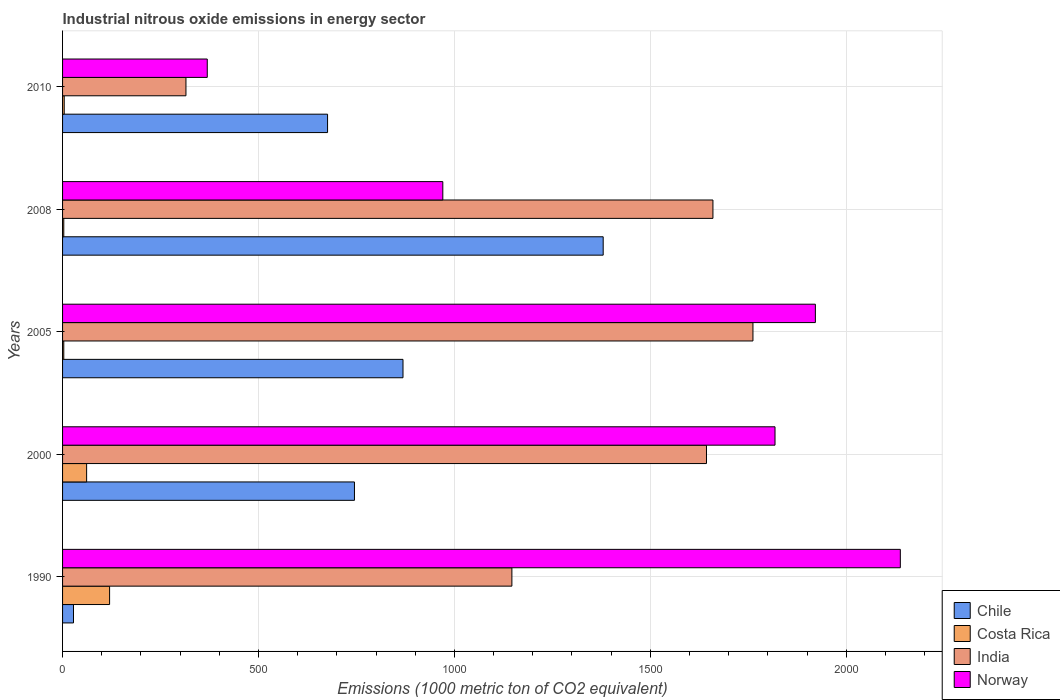How many bars are there on the 2nd tick from the bottom?
Offer a terse response. 4. In how many cases, is the number of bars for a given year not equal to the number of legend labels?
Ensure brevity in your answer.  0. Across all years, what is the maximum amount of industrial nitrous oxide emitted in Chile?
Your response must be concise. 1379.7. Across all years, what is the minimum amount of industrial nitrous oxide emitted in Chile?
Provide a succinct answer. 27.9. What is the total amount of industrial nitrous oxide emitted in India in the graph?
Your response must be concise. 6526.6. What is the difference between the amount of industrial nitrous oxide emitted in Costa Rica in 1990 and that in 2005?
Make the answer very short. 116.9. What is the difference between the amount of industrial nitrous oxide emitted in Chile in 1990 and the amount of industrial nitrous oxide emitted in Costa Rica in 2010?
Your response must be concise. 23.7. What is the average amount of industrial nitrous oxide emitted in India per year?
Make the answer very short. 1305.32. In the year 2010, what is the difference between the amount of industrial nitrous oxide emitted in Chile and amount of industrial nitrous oxide emitted in Costa Rica?
Provide a succinct answer. 672.1. In how many years, is the amount of industrial nitrous oxide emitted in Costa Rica greater than 700 1000 metric ton?
Provide a short and direct response. 0. What is the ratio of the amount of industrial nitrous oxide emitted in Norway in 2005 to that in 2010?
Offer a terse response. 5.2. Is the amount of industrial nitrous oxide emitted in India in 1990 less than that in 2000?
Keep it short and to the point. Yes. What is the difference between the highest and the second highest amount of industrial nitrous oxide emitted in Costa Rica?
Ensure brevity in your answer.  58.6. What is the difference between the highest and the lowest amount of industrial nitrous oxide emitted in Chile?
Provide a short and direct response. 1351.8. Is the sum of the amount of industrial nitrous oxide emitted in Norway in 1990 and 2010 greater than the maximum amount of industrial nitrous oxide emitted in India across all years?
Give a very brief answer. Yes. Is it the case that in every year, the sum of the amount of industrial nitrous oxide emitted in Chile and amount of industrial nitrous oxide emitted in India is greater than the sum of amount of industrial nitrous oxide emitted in Norway and amount of industrial nitrous oxide emitted in Costa Rica?
Ensure brevity in your answer.  Yes. What does the 1st bar from the top in 2005 represents?
Keep it short and to the point. Norway. What does the 4th bar from the bottom in 2008 represents?
Your answer should be compact. Norway. Is it the case that in every year, the sum of the amount of industrial nitrous oxide emitted in Costa Rica and amount of industrial nitrous oxide emitted in India is greater than the amount of industrial nitrous oxide emitted in Chile?
Your response must be concise. No. How many years are there in the graph?
Provide a short and direct response. 5. What is the difference between two consecutive major ticks on the X-axis?
Make the answer very short. 500. Does the graph contain any zero values?
Offer a terse response. No. How many legend labels are there?
Offer a terse response. 4. How are the legend labels stacked?
Provide a succinct answer. Vertical. What is the title of the graph?
Give a very brief answer. Industrial nitrous oxide emissions in energy sector. What is the label or title of the X-axis?
Give a very brief answer. Emissions (1000 metric ton of CO2 equivalent). What is the label or title of the Y-axis?
Your response must be concise. Years. What is the Emissions (1000 metric ton of CO2 equivalent) in Chile in 1990?
Ensure brevity in your answer.  27.9. What is the Emissions (1000 metric ton of CO2 equivalent) in Costa Rica in 1990?
Make the answer very short. 120. What is the Emissions (1000 metric ton of CO2 equivalent) of India in 1990?
Offer a terse response. 1146.7. What is the Emissions (1000 metric ton of CO2 equivalent) in Norway in 1990?
Ensure brevity in your answer.  2138. What is the Emissions (1000 metric ton of CO2 equivalent) of Chile in 2000?
Your answer should be compact. 744.9. What is the Emissions (1000 metric ton of CO2 equivalent) of Costa Rica in 2000?
Provide a succinct answer. 61.4. What is the Emissions (1000 metric ton of CO2 equivalent) of India in 2000?
Keep it short and to the point. 1643.3. What is the Emissions (1000 metric ton of CO2 equivalent) in Norway in 2000?
Provide a succinct answer. 1818.2. What is the Emissions (1000 metric ton of CO2 equivalent) in Chile in 2005?
Make the answer very short. 868.8. What is the Emissions (1000 metric ton of CO2 equivalent) of Costa Rica in 2005?
Your answer should be compact. 3.1. What is the Emissions (1000 metric ton of CO2 equivalent) in India in 2005?
Your answer should be compact. 1761.9. What is the Emissions (1000 metric ton of CO2 equivalent) in Norway in 2005?
Offer a very short reply. 1921.2. What is the Emissions (1000 metric ton of CO2 equivalent) of Chile in 2008?
Your answer should be compact. 1379.7. What is the Emissions (1000 metric ton of CO2 equivalent) of Costa Rica in 2008?
Your response must be concise. 3.1. What is the Emissions (1000 metric ton of CO2 equivalent) of India in 2008?
Your response must be concise. 1659.8. What is the Emissions (1000 metric ton of CO2 equivalent) in Norway in 2008?
Give a very brief answer. 970.4. What is the Emissions (1000 metric ton of CO2 equivalent) of Chile in 2010?
Provide a short and direct response. 676.3. What is the Emissions (1000 metric ton of CO2 equivalent) of Costa Rica in 2010?
Offer a terse response. 4.2. What is the Emissions (1000 metric ton of CO2 equivalent) in India in 2010?
Your response must be concise. 314.9. What is the Emissions (1000 metric ton of CO2 equivalent) in Norway in 2010?
Make the answer very short. 369.3. Across all years, what is the maximum Emissions (1000 metric ton of CO2 equivalent) in Chile?
Your response must be concise. 1379.7. Across all years, what is the maximum Emissions (1000 metric ton of CO2 equivalent) of Costa Rica?
Give a very brief answer. 120. Across all years, what is the maximum Emissions (1000 metric ton of CO2 equivalent) in India?
Your answer should be very brief. 1761.9. Across all years, what is the maximum Emissions (1000 metric ton of CO2 equivalent) in Norway?
Ensure brevity in your answer.  2138. Across all years, what is the minimum Emissions (1000 metric ton of CO2 equivalent) of Chile?
Your answer should be very brief. 27.9. Across all years, what is the minimum Emissions (1000 metric ton of CO2 equivalent) of India?
Offer a terse response. 314.9. Across all years, what is the minimum Emissions (1000 metric ton of CO2 equivalent) in Norway?
Your response must be concise. 369.3. What is the total Emissions (1000 metric ton of CO2 equivalent) in Chile in the graph?
Offer a very short reply. 3697.6. What is the total Emissions (1000 metric ton of CO2 equivalent) in Costa Rica in the graph?
Provide a short and direct response. 191.8. What is the total Emissions (1000 metric ton of CO2 equivalent) in India in the graph?
Your answer should be very brief. 6526.6. What is the total Emissions (1000 metric ton of CO2 equivalent) in Norway in the graph?
Provide a short and direct response. 7217.1. What is the difference between the Emissions (1000 metric ton of CO2 equivalent) of Chile in 1990 and that in 2000?
Offer a very short reply. -717. What is the difference between the Emissions (1000 metric ton of CO2 equivalent) in Costa Rica in 1990 and that in 2000?
Make the answer very short. 58.6. What is the difference between the Emissions (1000 metric ton of CO2 equivalent) of India in 1990 and that in 2000?
Make the answer very short. -496.6. What is the difference between the Emissions (1000 metric ton of CO2 equivalent) of Norway in 1990 and that in 2000?
Provide a short and direct response. 319.8. What is the difference between the Emissions (1000 metric ton of CO2 equivalent) of Chile in 1990 and that in 2005?
Your answer should be very brief. -840.9. What is the difference between the Emissions (1000 metric ton of CO2 equivalent) of Costa Rica in 1990 and that in 2005?
Make the answer very short. 116.9. What is the difference between the Emissions (1000 metric ton of CO2 equivalent) in India in 1990 and that in 2005?
Offer a terse response. -615.2. What is the difference between the Emissions (1000 metric ton of CO2 equivalent) of Norway in 1990 and that in 2005?
Ensure brevity in your answer.  216.8. What is the difference between the Emissions (1000 metric ton of CO2 equivalent) of Chile in 1990 and that in 2008?
Give a very brief answer. -1351.8. What is the difference between the Emissions (1000 metric ton of CO2 equivalent) of Costa Rica in 1990 and that in 2008?
Provide a short and direct response. 116.9. What is the difference between the Emissions (1000 metric ton of CO2 equivalent) in India in 1990 and that in 2008?
Offer a very short reply. -513.1. What is the difference between the Emissions (1000 metric ton of CO2 equivalent) of Norway in 1990 and that in 2008?
Your answer should be very brief. 1167.6. What is the difference between the Emissions (1000 metric ton of CO2 equivalent) of Chile in 1990 and that in 2010?
Ensure brevity in your answer.  -648.4. What is the difference between the Emissions (1000 metric ton of CO2 equivalent) of Costa Rica in 1990 and that in 2010?
Offer a terse response. 115.8. What is the difference between the Emissions (1000 metric ton of CO2 equivalent) of India in 1990 and that in 2010?
Give a very brief answer. 831.8. What is the difference between the Emissions (1000 metric ton of CO2 equivalent) in Norway in 1990 and that in 2010?
Give a very brief answer. 1768.7. What is the difference between the Emissions (1000 metric ton of CO2 equivalent) in Chile in 2000 and that in 2005?
Your response must be concise. -123.9. What is the difference between the Emissions (1000 metric ton of CO2 equivalent) in Costa Rica in 2000 and that in 2005?
Offer a very short reply. 58.3. What is the difference between the Emissions (1000 metric ton of CO2 equivalent) in India in 2000 and that in 2005?
Your answer should be very brief. -118.6. What is the difference between the Emissions (1000 metric ton of CO2 equivalent) of Norway in 2000 and that in 2005?
Ensure brevity in your answer.  -103. What is the difference between the Emissions (1000 metric ton of CO2 equivalent) of Chile in 2000 and that in 2008?
Give a very brief answer. -634.8. What is the difference between the Emissions (1000 metric ton of CO2 equivalent) of Costa Rica in 2000 and that in 2008?
Ensure brevity in your answer.  58.3. What is the difference between the Emissions (1000 metric ton of CO2 equivalent) in India in 2000 and that in 2008?
Make the answer very short. -16.5. What is the difference between the Emissions (1000 metric ton of CO2 equivalent) in Norway in 2000 and that in 2008?
Offer a terse response. 847.8. What is the difference between the Emissions (1000 metric ton of CO2 equivalent) in Chile in 2000 and that in 2010?
Give a very brief answer. 68.6. What is the difference between the Emissions (1000 metric ton of CO2 equivalent) in Costa Rica in 2000 and that in 2010?
Your answer should be very brief. 57.2. What is the difference between the Emissions (1000 metric ton of CO2 equivalent) of India in 2000 and that in 2010?
Make the answer very short. 1328.4. What is the difference between the Emissions (1000 metric ton of CO2 equivalent) in Norway in 2000 and that in 2010?
Ensure brevity in your answer.  1448.9. What is the difference between the Emissions (1000 metric ton of CO2 equivalent) of Chile in 2005 and that in 2008?
Your response must be concise. -510.9. What is the difference between the Emissions (1000 metric ton of CO2 equivalent) of India in 2005 and that in 2008?
Keep it short and to the point. 102.1. What is the difference between the Emissions (1000 metric ton of CO2 equivalent) of Norway in 2005 and that in 2008?
Provide a short and direct response. 950.8. What is the difference between the Emissions (1000 metric ton of CO2 equivalent) of Chile in 2005 and that in 2010?
Keep it short and to the point. 192.5. What is the difference between the Emissions (1000 metric ton of CO2 equivalent) of India in 2005 and that in 2010?
Provide a succinct answer. 1447. What is the difference between the Emissions (1000 metric ton of CO2 equivalent) in Norway in 2005 and that in 2010?
Offer a very short reply. 1551.9. What is the difference between the Emissions (1000 metric ton of CO2 equivalent) of Chile in 2008 and that in 2010?
Your answer should be compact. 703.4. What is the difference between the Emissions (1000 metric ton of CO2 equivalent) in India in 2008 and that in 2010?
Keep it short and to the point. 1344.9. What is the difference between the Emissions (1000 metric ton of CO2 equivalent) in Norway in 2008 and that in 2010?
Keep it short and to the point. 601.1. What is the difference between the Emissions (1000 metric ton of CO2 equivalent) in Chile in 1990 and the Emissions (1000 metric ton of CO2 equivalent) in Costa Rica in 2000?
Ensure brevity in your answer.  -33.5. What is the difference between the Emissions (1000 metric ton of CO2 equivalent) of Chile in 1990 and the Emissions (1000 metric ton of CO2 equivalent) of India in 2000?
Offer a very short reply. -1615.4. What is the difference between the Emissions (1000 metric ton of CO2 equivalent) of Chile in 1990 and the Emissions (1000 metric ton of CO2 equivalent) of Norway in 2000?
Make the answer very short. -1790.3. What is the difference between the Emissions (1000 metric ton of CO2 equivalent) in Costa Rica in 1990 and the Emissions (1000 metric ton of CO2 equivalent) in India in 2000?
Give a very brief answer. -1523.3. What is the difference between the Emissions (1000 metric ton of CO2 equivalent) of Costa Rica in 1990 and the Emissions (1000 metric ton of CO2 equivalent) of Norway in 2000?
Your response must be concise. -1698.2. What is the difference between the Emissions (1000 metric ton of CO2 equivalent) of India in 1990 and the Emissions (1000 metric ton of CO2 equivalent) of Norway in 2000?
Provide a short and direct response. -671.5. What is the difference between the Emissions (1000 metric ton of CO2 equivalent) of Chile in 1990 and the Emissions (1000 metric ton of CO2 equivalent) of Costa Rica in 2005?
Your answer should be compact. 24.8. What is the difference between the Emissions (1000 metric ton of CO2 equivalent) in Chile in 1990 and the Emissions (1000 metric ton of CO2 equivalent) in India in 2005?
Provide a short and direct response. -1734. What is the difference between the Emissions (1000 metric ton of CO2 equivalent) in Chile in 1990 and the Emissions (1000 metric ton of CO2 equivalent) in Norway in 2005?
Offer a very short reply. -1893.3. What is the difference between the Emissions (1000 metric ton of CO2 equivalent) of Costa Rica in 1990 and the Emissions (1000 metric ton of CO2 equivalent) of India in 2005?
Keep it short and to the point. -1641.9. What is the difference between the Emissions (1000 metric ton of CO2 equivalent) of Costa Rica in 1990 and the Emissions (1000 metric ton of CO2 equivalent) of Norway in 2005?
Your answer should be compact. -1801.2. What is the difference between the Emissions (1000 metric ton of CO2 equivalent) of India in 1990 and the Emissions (1000 metric ton of CO2 equivalent) of Norway in 2005?
Provide a short and direct response. -774.5. What is the difference between the Emissions (1000 metric ton of CO2 equivalent) of Chile in 1990 and the Emissions (1000 metric ton of CO2 equivalent) of Costa Rica in 2008?
Provide a short and direct response. 24.8. What is the difference between the Emissions (1000 metric ton of CO2 equivalent) in Chile in 1990 and the Emissions (1000 metric ton of CO2 equivalent) in India in 2008?
Make the answer very short. -1631.9. What is the difference between the Emissions (1000 metric ton of CO2 equivalent) of Chile in 1990 and the Emissions (1000 metric ton of CO2 equivalent) of Norway in 2008?
Provide a succinct answer. -942.5. What is the difference between the Emissions (1000 metric ton of CO2 equivalent) in Costa Rica in 1990 and the Emissions (1000 metric ton of CO2 equivalent) in India in 2008?
Give a very brief answer. -1539.8. What is the difference between the Emissions (1000 metric ton of CO2 equivalent) of Costa Rica in 1990 and the Emissions (1000 metric ton of CO2 equivalent) of Norway in 2008?
Offer a very short reply. -850.4. What is the difference between the Emissions (1000 metric ton of CO2 equivalent) of India in 1990 and the Emissions (1000 metric ton of CO2 equivalent) of Norway in 2008?
Offer a terse response. 176.3. What is the difference between the Emissions (1000 metric ton of CO2 equivalent) of Chile in 1990 and the Emissions (1000 metric ton of CO2 equivalent) of Costa Rica in 2010?
Give a very brief answer. 23.7. What is the difference between the Emissions (1000 metric ton of CO2 equivalent) in Chile in 1990 and the Emissions (1000 metric ton of CO2 equivalent) in India in 2010?
Make the answer very short. -287. What is the difference between the Emissions (1000 metric ton of CO2 equivalent) of Chile in 1990 and the Emissions (1000 metric ton of CO2 equivalent) of Norway in 2010?
Keep it short and to the point. -341.4. What is the difference between the Emissions (1000 metric ton of CO2 equivalent) of Costa Rica in 1990 and the Emissions (1000 metric ton of CO2 equivalent) of India in 2010?
Ensure brevity in your answer.  -194.9. What is the difference between the Emissions (1000 metric ton of CO2 equivalent) in Costa Rica in 1990 and the Emissions (1000 metric ton of CO2 equivalent) in Norway in 2010?
Your answer should be compact. -249.3. What is the difference between the Emissions (1000 metric ton of CO2 equivalent) of India in 1990 and the Emissions (1000 metric ton of CO2 equivalent) of Norway in 2010?
Your answer should be very brief. 777.4. What is the difference between the Emissions (1000 metric ton of CO2 equivalent) in Chile in 2000 and the Emissions (1000 metric ton of CO2 equivalent) in Costa Rica in 2005?
Keep it short and to the point. 741.8. What is the difference between the Emissions (1000 metric ton of CO2 equivalent) in Chile in 2000 and the Emissions (1000 metric ton of CO2 equivalent) in India in 2005?
Offer a terse response. -1017. What is the difference between the Emissions (1000 metric ton of CO2 equivalent) of Chile in 2000 and the Emissions (1000 metric ton of CO2 equivalent) of Norway in 2005?
Your response must be concise. -1176.3. What is the difference between the Emissions (1000 metric ton of CO2 equivalent) of Costa Rica in 2000 and the Emissions (1000 metric ton of CO2 equivalent) of India in 2005?
Provide a succinct answer. -1700.5. What is the difference between the Emissions (1000 metric ton of CO2 equivalent) of Costa Rica in 2000 and the Emissions (1000 metric ton of CO2 equivalent) of Norway in 2005?
Keep it short and to the point. -1859.8. What is the difference between the Emissions (1000 metric ton of CO2 equivalent) of India in 2000 and the Emissions (1000 metric ton of CO2 equivalent) of Norway in 2005?
Offer a very short reply. -277.9. What is the difference between the Emissions (1000 metric ton of CO2 equivalent) in Chile in 2000 and the Emissions (1000 metric ton of CO2 equivalent) in Costa Rica in 2008?
Give a very brief answer. 741.8. What is the difference between the Emissions (1000 metric ton of CO2 equivalent) of Chile in 2000 and the Emissions (1000 metric ton of CO2 equivalent) of India in 2008?
Your response must be concise. -914.9. What is the difference between the Emissions (1000 metric ton of CO2 equivalent) of Chile in 2000 and the Emissions (1000 metric ton of CO2 equivalent) of Norway in 2008?
Offer a very short reply. -225.5. What is the difference between the Emissions (1000 metric ton of CO2 equivalent) in Costa Rica in 2000 and the Emissions (1000 metric ton of CO2 equivalent) in India in 2008?
Offer a very short reply. -1598.4. What is the difference between the Emissions (1000 metric ton of CO2 equivalent) of Costa Rica in 2000 and the Emissions (1000 metric ton of CO2 equivalent) of Norway in 2008?
Give a very brief answer. -909. What is the difference between the Emissions (1000 metric ton of CO2 equivalent) of India in 2000 and the Emissions (1000 metric ton of CO2 equivalent) of Norway in 2008?
Offer a very short reply. 672.9. What is the difference between the Emissions (1000 metric ton of CO2 equivalent) in Chile in 2000 and the Emissions (1000 metric ton of CO2 equivalent) in Costa Rica in 2010?
Offer a very short reply. 740.7. What is the difference between the Emissions (1000 metric ton of CO2 equivalent) of Chile in 2000 and the Emissions (1000 metric ton of CO2 equivalent) of India in 2010?
Ensure brevity in your answer.  430. What is the difference between the Emissions (1000 metric ton of CO2 equivalent) in Chile in 2000 and the Emissions (1000 metric ton of CO2 equivalent) in Norway in 2010?
Give a very brief answer. 375.6. What is the difference between the Emissions (1000 metric ton of CO2 equivalent) of Costa Rica in 2000 and the Emissions (1000 metric ton of CO2 equivalent) of India in 2010?
Give a very brief answer. -253.5. What is the difference between the Emissions (1000 metric ton of CO2 equivalent) in Costa Rica in 2000 and the Emissions (1000 metric ton of CO2 equivalent) in Norway in 2010?
Offer a very short reply. -307.9. What is the difference between the Emissions (1000 metric ton of CO2 equivalent) in India in 2000 and the Emissions (1000 metric ton of CO2 equivalent) in Norway in 2010?
Offer a terse response. 1274. What is the difference between the Emissions (1000 metric ton of CO2 equivalent) in Chile in 2005 and the Emissions (1000 metric ton of CO2 equivalent) in Costa Rica in 2008?
Your answer should be very brief. 865.7. What is the difference between the Emissions (1000 metric ton of CO2 equivalent) in Chile in 2005 and the Emissions (1000 metric ton of CO2 equivalent) in India in 2008?
Provide a short and direct response. -791. What is the difference between the Emissions (1000 metric ton of CO2 equivalent) in Chile in 2005 and the Emissions (1000 metric ton of CO2 equivalent) in Norway in 2008?
Provide a succinct answer. -101.6. What is the difference between the Emissions (1000 metric ton of CO2 equivalent) in Costa Rica in 2005 and the Emissions (1000 metric ton of CO2 equivalent) in India in 2008?
Give a very brief answer. -1656.7. What is the difference between the Emissions (1000 metric ton of CO2 equivalent) in Costa Rica in 2005 and the Emissions (1000 metric ton of CO2 equivalent) in Norway in 2008?
Offer a terse response. -967.3. What is the difference between the Emissions (1000 metric ton of CO2 equivalent) of India in 2005 and the Emissions (1000 metric ton of CO2 equivalent) of Norway in 2008?
Provide a succinct answer. 791.5. What is the difference between the Emissions (1000 metric ton of CO2 equivalent) in Chile in 2005 and the Emissions (1000 metric ton of CO2 equivalent) in Costa Rica in 2010?
Make the answer very short. 864.6. What is the difference between the Emissions (1000 metric ton of CO2 equivalent) of Chile in 2005 and the Emissions (1000 metric ton of CO2 equivalent) of India in 2010?
Keep it short and to the point. 553.9. What is the difference between the Emissions (1000 metric ton of CO2 equivalent) in Chile in 2005 and the Emissions (1000 metric ton of CO2 equivalent) in Norway in 2010?
Your answer should be very brief. 499.5. What is the difference between the Emissions (1000 metric ton of CO2 equivalent) of Costa Rica in 2005 and the Emissions (1000 metric ton of CO2 equivalent) of India in 2010?
Your answer should be compact. -311.8. What is the difference between the Emissions (1000 metric ton of CO2 equivalent) of Costa Rica in 2005 and the Emissions (1000 metric ton of CO2 equivalent) of Norway in 2010?
Your response must be concise. -366.2. What is the difference between the Emissions (1000 metric ton of CO2 equivalent) of India in 2005 and the Emissions (1000 metric ton of CO2 equivalent) of Norway in 2010?
Offer a very short reply. 1392.6. What is the difference between the Emissions (1000 metric ton of CO2 equivalent) in Chile in 2008 and the Emissions (1000 metric ton of CO2 equivalent) in Costa Rica in 2010?
Give a very brief answer. 1375.5. What is the difference between the Emissions (1000 metric ton of CO2 equivalent) of Chile in 2008 and the Emissions (1000 metric ton of CO2 equivalent) of India in 2010?
Provide a short and direct response. 1064.8. What is the difference between the Emissions (1000 metric ton of CO2 equivalent) of Chile in 2008 and the Emissions (1000 metric ton of CO2 equivalent) of Norway in 2010?
Keep it short and to the point. 1010.4. What is the difference between the Emissions (1000 metric ton of CO2 equivalent) of Costa Rica in 2008 and the Emissions (1000 metric ton of CO2 equivalent) of India in 2010?
Your response must be concise. -311.8. What is the difference between the Emissions (1000 metric ton of CO2 equivalent) in Costa Rica in 2008 and the Emissions (1000 metric ton of CO2 equivalent) in Norway in 2010?
Ensure brevity in your answer.  -366.2. What is the difference between the Emissions (1000 metric ton of CO2 equivalent) of India in 2008 and the Emissions (1000 metric ton of CO2 equivalent) of Norway in 2010?
Provide a succinct answer. 1290.5. What is the average Emissions (1000 metric ton of CO2 equivalent) in Chile per year?
Ensure brevity in your answer.  739.52. What is the average Emissions (1000 metric ton of CO2 equivalent) of Costa Rica per year?
Keep it short and to the point. 38.36. What is the average Emissions (1000 metric ton of CO2 equivalent) in India per year?
Offer a terse response. 1305.32. What is the average Emissions (1000 metric ton of CO2 equivalent) of Norway per year?
Your answer should be compact. 1443.42. In the year 1990, what is the difference between the Emissions (1000 metric ton of CO2 equivalent) in Chile and Emissions (1000 metric ton of CO2 equivalent) in Costa Rica?
Your response must be concise. -92.1. In the year 1990, what is the difference between the Emissions (1000 metric ton of CO2 equivalent) in Chile and Emissions (1000 metric ton of CO2 equivalent) in India?
Provide a succinct answer. -1118.8. In the year 1990, what is the difference between the Emissions (1000 metric ton of CO2 equivalent) of Chile and Emissions (1000 metric ton of CO2 equivalent) of Norway?
Offer a very short reply. -2110.1. In the year 1990, what is the difference between the Emissions (1000 metric ton of CO2 equivalent) of Costa Rica and Emissions (1000 metric ton of CO2 equivalent) of India?
Your answer should be compact. -1026.7. In the year 1990, what is the difference between the Emissions (1000 metric ton of CO2 equivalent) of Costa Rica and Emissions (1000 metric ton of CO2 equivalent) of Norway?
Your answer should be very brief. -2018. In the year 1990, what is the difference between the Emissions (1000 metric ton of CO2 equivalent) of India and Emissions (1000 metric ton of CO2 equivalent) of Norway?
Your response must be concise. -991.3. In the year 2000, what is the difference between the Emissions (1000 metric ton of CO2 equivalent) in Chile and Emissions (1000 metric ton of CO2 equivalent) in Costa Rica?
Offer a terse response. 683.5. In the year 2000, what is the difference between the Emissions (1000 metric ton of CO2 equivalent) of Chile and Emissions (1000 metric ton of CO2 equivalent) of India?
Make the answer very short. -898.4. In the year 2000, what is the difference between the Emissions (1000 metric ton of CO2 equivalent) of Chile and Emissions (1000 metric ton of CO2 equivalent) of Norway?
Offer a very short reply. -1073.3. In the year 2000, what is the difference between the Emissions (1000 metric ton of CO2 equivalent) in Costa Rica and Emissions (1000 metric ton of CO2 equivalent) in India?
Your answer should be compact. -1581.9. In the year 2000, what is the difference between the Emissions (1000 metric ton of CO2 equivalent) of Costa Rica and Emissions (1000 metric ton of CO2 equivalent) of Norway?
Give a very brief answer. -1756.8. In the year 2000, what is the difference between the Emissions (1000 metric ton of CO2 equivalent) in India and Emissions (1000 metric ton of CO2 equivalent) in Norway?
Your answer should be compact. -174.9. In the year 2005, what is the difference between the Emissions (1000 metric ton of CO2 equivalent) in Chile and Emissions (1000 metric ton of CO2 equivalent) in Costa Rica?
Ensure brevity in your answer.  865.7. In the year 2005, what is the difference between the Emissions (1000 metric ton of CO2 equivalent) of Chile and Emissions (1000 metric ton of CO2 equivalent) of India?
Ensure brevity in your answer.  -893.1. In the year 2005, what is the difference between the Emissions (1000 metric ton of CO2 equivalent) of Chile and Emissions (1000 metric ton of CO2 equivalent) of Norway?
Keep it short and to the point. -1052.4. In the year 2005, what is the difference between the Emissions (1000 metric ton of CO2 equivalent) in Costa Rica and Emissions (1000 metric ton of CO2 equivalent) in India?
Keep it short and to the point. -1758.8. In the year 2005, what is the difference between the Emissions (1000 metric ton of CO2 equivalent) in Costa Rica and Emissions (1000 metric ton of CO2 equivalent) in Norway?
Provide a succinct answer. -1918.1. In the year 2005, what is the difference between the Emissions (1000 metric ton of CO2 equivalent) of India and Emissions (1000 metric ton of CO2 equivalent) of Norway?
Offer a very short reply. -159.3. In the year 2008, what is the difference between the Emissions (1000 metric ton of CO2 equivalent) of Chile and Emissions (1000 metric ton of CO2 equivalent) of Costa Rica?
Your answer should be compact. 1376.6. In the year 2008, what is the difference between the Emissions (1000 metric ton of CO2 equivalent) in Chile and Emissions (1000 metric ton of CO2 equivalent) in India?
Your response must be concise. -280.1. In the year 2008, what is the difference between the Emissions (1000 metric ton of CO2 equivalent) of Chile and Emissions (1000 metric ton of CO2 equivalent) of Norway?
Your answer should be very brief. 409.3. In the year 2008, what is the difference between the Emissions (1000 metric ton of CO2 equivalent) in Costa Rica and Emissions (1000 metric ton of CO2 equivalent) in India?
Ensure brevity in your answer.  -1656.7. In the year 2008, what is the difference between the Emissions (1000 metric ton of CO2 equivalent) in Costa Rica and Emissions (1000 metric ton of CO2 equivalent) in Norway?
Your response must be concise. -967.3. In the year 2008, what is the difference between the Emissions (1000 metric ton of CO2 equivalent) in India and Emissions (1000 metric ton of CO2 equivalent) in Norway?
Your answer should be compact. 689.4. In the year 2010, what is the difference between the Emissions (1000 metric ton of CO2 equivalent) in Chile and Emissions (1000 metric ton of CO2 equivalent) in Costa Rica?
Keep it short and to the point. 672.1. In the year 2010, what is the difference between the Emissions (1000 metric ton of CO2 equivalent) in Chile and Emissions (1000 metric ton of CO2 equivalent) in India?
Provide a succinct answer. 361.4. In the year 2010, what is the difference between the Emissions (1000 metric ton of CO2 equivalent) of Chile and Emissions (1000 metric ton of CO2 equivalent) of Norway?
Your answer should be very brief. 307. In the year 2010, what is the difference between the Emissions (1000 metric ton of CO2 equivalent) in Costa Rica and Emissions (1000 metric ton of CO2 equivalent) in India?
Your response must be concise. -310.7. In the year 2010, what is the difference between the Emissions (1000 metric ton of CO2 equivalent) of Costa Rica and Emissions (1000 metric ton of CO2 equivalent) of Norway?
Give a very brief answer. -365.1. In the year 2010, what is the difference between the Emissions (1000 metric ton of CO2 equivalent) of India and Emissions (1000 metric ton of CO2 equivalent) of Norway?
Provide a succinct answer. -54.4. What is the ratio of the Emissions (1000 metric ton of CO2 equivalent) of Chile in 1990 to that in 2000?
Provide a short and direct response. 0.04. What is the ratio of the Emissions (1000 metric ton of CO2 equivalent) in Costa Rica in 1990 to that in 2000?
Your response must be concise. 1.95. What is the ratio of the Emissions (1000 metric ton of CO2 equivalent) in India in 1990 to that in 2000?
Your answer should be compact. 0.7. What is the ratio of the Emissions (1000 metric ton of CO2 equivalent) in Norway in 1990 to that in 2000?
Ensure brevity in your answer.  1.18. What is the ratio of the Emissions (1000 metric ton of CO2 equivalent) of Chile in 1990 to that in 2005?
Make the answer very short. 0.03. What is the ratio of the Emissions (1000 metric ton of CO2 equivalent) in Costa Rica in 1990 to that in 2005?
Provide a succinct answer. 38.71. What is the ratio of the Emissions (1000 metric ton of CO2 equivalent) in India in 1990 to that in 2005?
Your answer should be very brief. 0.65. What is the ratio of the Emissions (1000 metric ton of CO2 equivalent) in Norway in 1990 to that in 2005?
Offer a terse response. 1.11. What is the ratio of the Emissions (1000 metric ton of CO2 equivalent) in Chile in 1990 to that in 2008?
Your response must be concise. 0.02. What is the ratio of the Emissions (1000 metric ton of CO2 equivalent) of Costa Rica in 1990 to that in 2008?
Make the answer very short. 38.71. What is the ratio of the Emissions (1000 metric ton of CO2 equivalent) of India in 1990 to that in 2008?
Ensure brevity in your answer.  0.69. What is the ratio of the Emissions (1000 metric ton of CO2 equivalent) of Norway in 1990 to that in 2008?
Your response must be concise. 2.2. What is the ratio of the Emissions (1000 metric ton of CO2 equivalent) in Chile in 1990 to that in 2010?
Keep it short and to the point. 0.04. What is the ratio of the Emissions (1000 metric ton of CO2 equivalent) in Costa Rica in 1990 to that in 2010?
Offer a terse response. 28.57. What is the ratio of the Emissions (1000 metric ton of CO2 equivalent) of India in 1990 to that in 2010?
Provide a succinct answer. 3.64. What is the ratio of the Emissions (1000 metric ton of CO2 equivalent) of Norway in 1990 to that in 2010?
Your response must be concise. 5.79. What is the ratio of the Emissions (1000 metric ton of CO2 equivalent) of Chile in 2000 to that in 2005?
Make the answer very short. 0.86. What is the ratio of the Emissions (1000 metric ton of CO2 equivalent) of Costa Rica in 2000 to that in 2005?
Your answer should be very brief. 19.81. What is the ratio of the Emissions (1000 metric ton of CO2 equivalent) of India in 2000 to that in 2005?
Ensure brevity in your answer.  0.93. What is the ratio of the Emissions (1000 metric ton of CO2 equivalent) in Norway in 2000 to that in 2005?
Offer a terse response. 0.95. What is the ratio of the Emissions (1000 metric ton of CO2 equivalent) in Chile in 2000 to that in 2008?
Give a very brief answer. 0.54. What is the ratio of the Emissions (1000 metric ton of CO2 equivalent) in Costa Rica in 2000 to that in 2008?
Offer a very short reply. 19.81. What is the ratio of the Emissions (1000 metric ton of CO2 equivalent) in Norway in 2000 to that in 2008?
Offer a very short reply. 1.87. What is the ratio of the Emissions (1000 metric ton of CO2 equivalent) of Chile in 2000 to that in 2010?
Keep it short and to the point. 1.1. What is the ratio of the Emissions (1000 metric ton of CO2 equivalent) of Costa Rica in 2000 to that in 2010?
Give a very brief answer. 14.62. What is the ratio of the Emissions (1000 metric ton of CO2 equivalent) of India in 2000 to that in 2010?
Your answer should be compact. 5.22. What is the ratio of the Emissions (1000 metric ton of CO2 equivalent) of Norway in 2000 to that in 2010?
Offer a very short reply. 4.92. What is the ratio of the Emissions (1000 metric ton of CO2 equivalent) in Chile in 2005 to that in 2008?
Your response must be concise. 0.63. What is the ratio of the Emissions (1000 metric ton of CO2 equivalent) in India in 2005 to that in 2008?
Your response must be concise. 1.06. What is the ratio of the Emissions (1000 metric ton of CO2 equivalent) of Norway in 2005 to that in 2008?
Provide a short and direct response. 1.98. What is the ratio of the Emissions (1000 metric ton of CO2 equivalent) of Chile in 2005 to that in 2010?
Provide a short and direct response. 1.28. What is the ratio of the Emissions (1000 metric ton of CO2 equivalent) of Costa Rica in 2005 to that in 2010?
Provide a succinct answer. 0.74. What is the ratio of the Emissions (1000 metric ton of CO2 equivalent) of India in 2005 to that in 2010?
Provide a succinct answer. 5.6. What is the ratio of the Emissions (1000 metric ton of CO2 equivalent) of Norway in 2005 to that in 2010?
Your answer should be very brief. 5.2. What is the ratio of the Emissions (1000 metric ton of CO2 equivalent) in Chile in 2008 to that in 2010?
Your answer should be compact. 2.04. What is the ratio of the Emissions (1000 metric ton of CO2 equivalent) of Costa Rica in 2008 to that in 2010?
Give a very brief answer. 0.74. What is the ratio of the Emissions (1000 metric ton of CO2 equivalent) of India in 2008 to that in 2010?
Provide a short and direct response. 5.27. What is the ratio of the Emissions (1000 metric ton of CO2 equivalent) of Norway in 2008 to that in 2010?
Your response must be concise. 2.63. What is the difference between the highest and the second highest Emissions (1000 metric ton of CO2 equivalent) in Chile?
Your answer should be compact. 510.9. What is the difference between the highest and the second highest Emissions (1000 metric ton of CO2 equivalent) in Costa Rica?
Your response must be concise. 58.6. What is the difference between the highest and the second highest Emissions (1000 metric ton of CO2 equivalent) in India?
Your response must be concise. 102.1. What is the difference between the highest and the second highest Emissions (1000 metric ton of CO2 equivalent) in Norway?
Your answer should be compact. 216.8. What is the difference between the highest and the lowest Emissions (1000 metric ton of CO2 equivalent) in Chile?
Offer a terse response. 1351.8. What is the difference between the highest and the lowest Emissions (1000 metric ton of CO2 equivalent) of Costa Rica?
Your answer should be very brief. 116.9. What is the difference between the highest and the lowest Emissions (1000 metric ton of CO2 equivalent) of India?
Your response must be concise. 1447. What is the difference between the highest and the lowest Emissions (1000 metric ton of CO2 equivalent) in Norway?
Your answer should be very brief. 1768.7. 